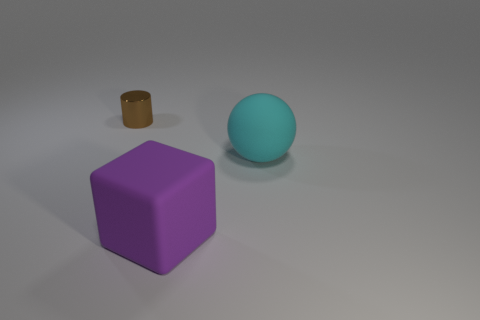Are there more balls behind the purple cube than tiny blue metallic cylinders?
Provide a short and direct response. Yes. There is a big object that is behind the large block; what is its color?
Give a very brief answer. Cyan. Is the cyan matte thing the same size as the cube?
Provide a short and direct response. Yes. What is the size of the purple matte cube?
Ensure brevity in your answer.  Large. Is the number of rubber cubes greater than the number of objects?
Your answer should be very brief. No. The big thing that is in front of the big rubber thing right of the matte object left of the cyan matte ball is what color?
Offer a very short reply. Purple. What is the color of the ball that is the same size as the purple rubber block?
Your answer should be very brief. Cyan. How many brown things are there?
Ensure brevity in your answer.  1. Does the large thing that is behind the large purple matte thing have the same material as the large purple cube?
Provide a short and direct response. Yes. What material is the object that is left of the rubber ball and behind the purple object?
Your answer should be compact. Metal. 